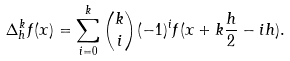<formula> <loc_0><loc_0><loc_500><loc_500>\Delta _ { h } ^ { k } f ( x ) = \sum _ { i = 0 } ^ { k } { k \choose i } ( - 1 ) ^ { i } f ( x + k \frac { h } { 2 } - i h ) .</formula> 